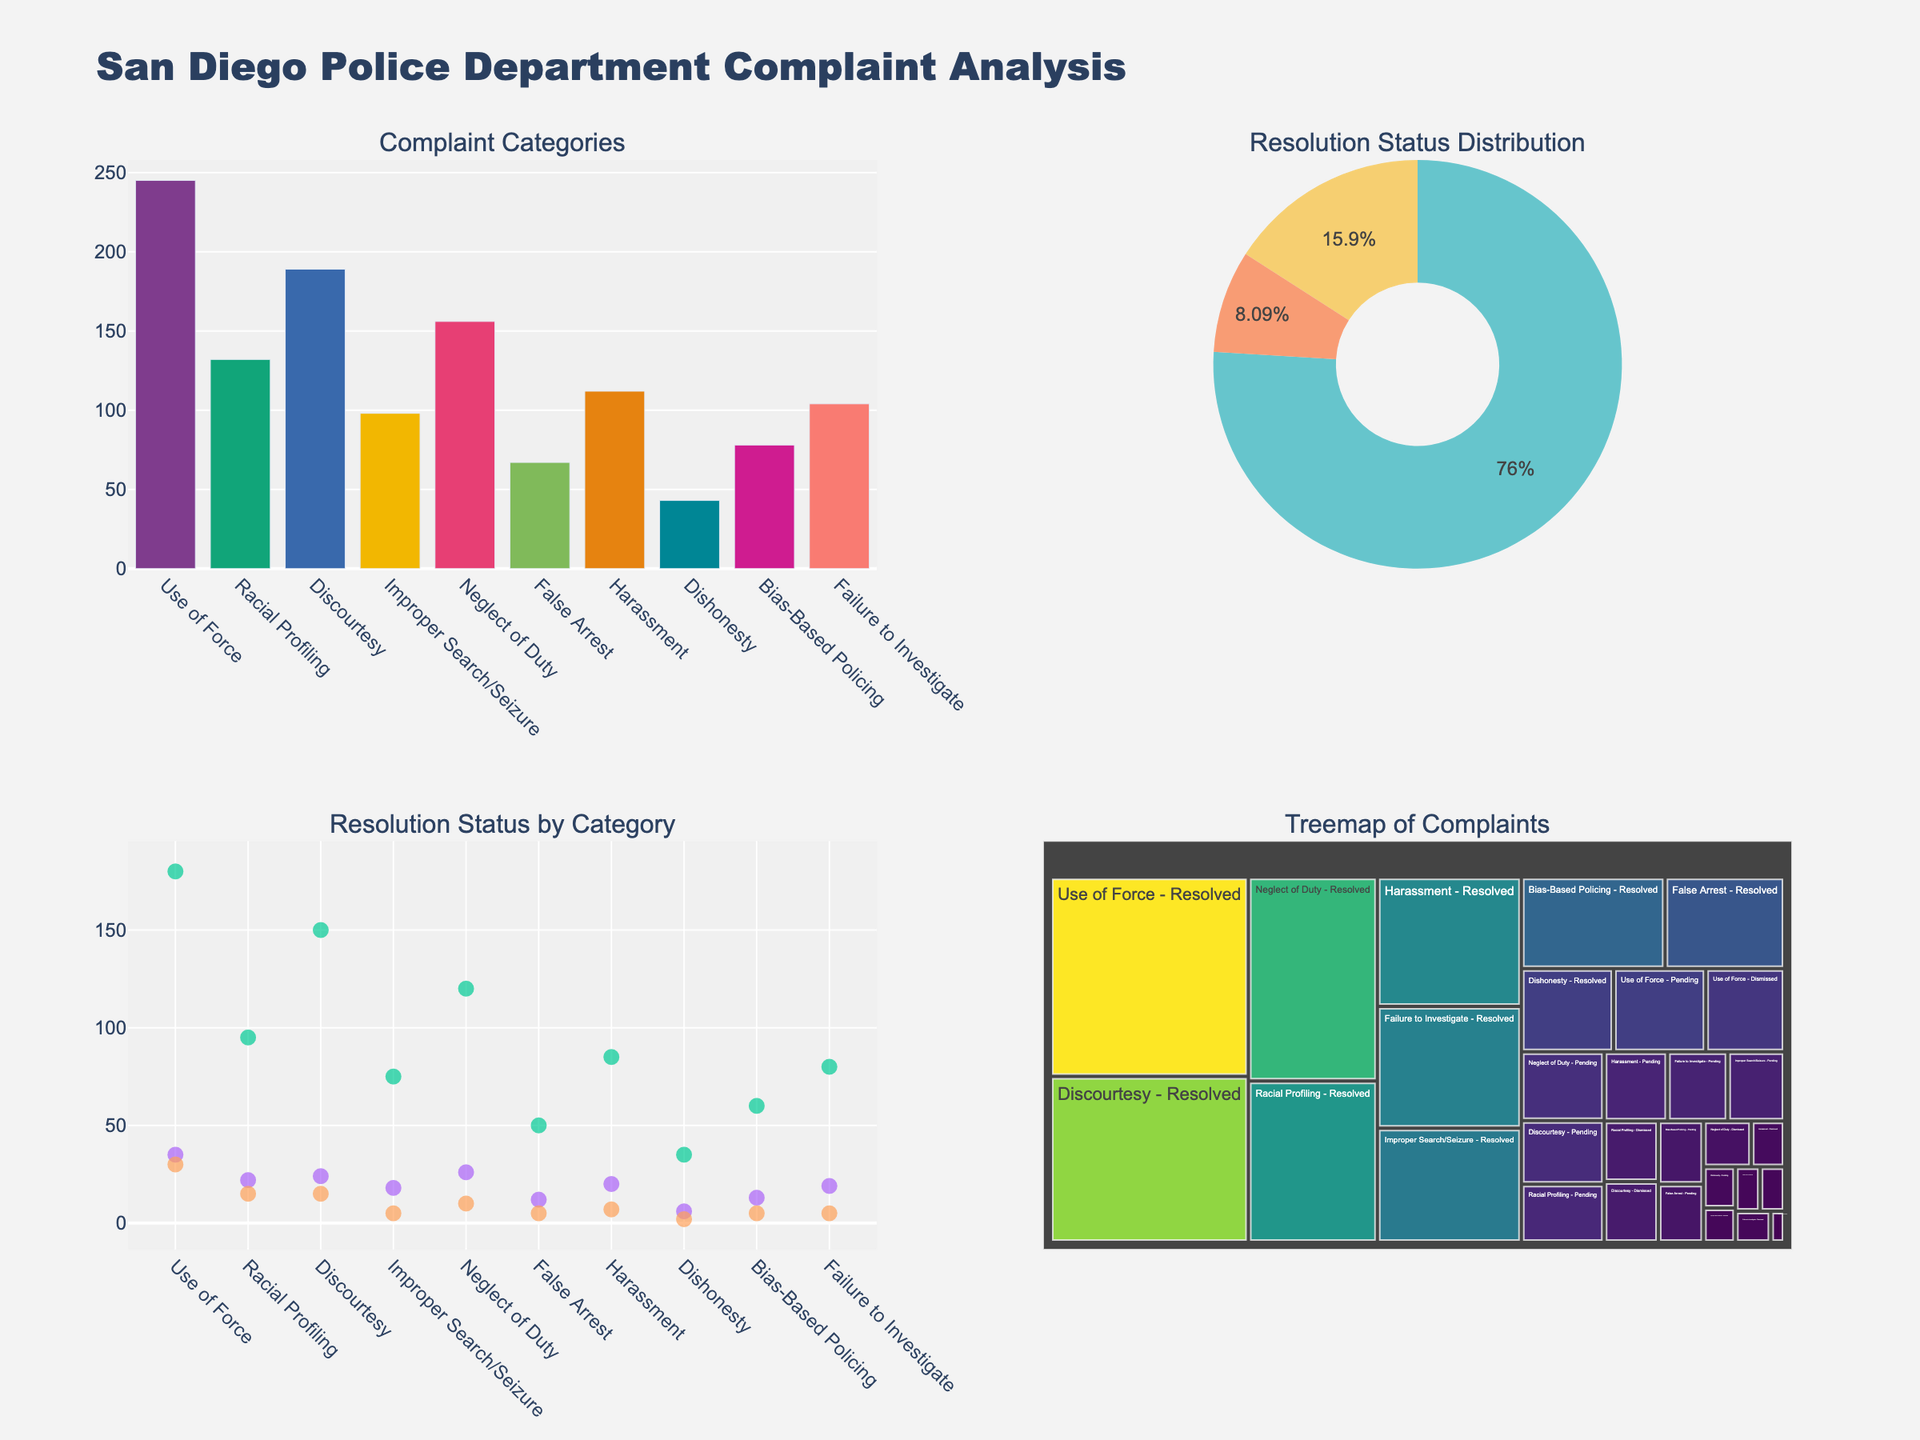What is the title of the overall figure? The title of the overall figure is found at the top and it provides a summary of the content of the figure. The title is "San Diego Police Department Complaint Analysis".
Answer: San Diego Police Department Complaint Analysis How many categories of complaints are there? By looking at the bar chart, we can count the number of distinct categories on the x-axis. There are 10 categories listed which include Use of Force, Racial Profiling, and so on.
Answer: 10 Which complaint category has the most total complaints? In the bar chart, we look for the bar that is the tallest, indicating the highest number of total complaints. The "Use of Force" category has the tallest bar.
Answer: Use of Force What is the total number of "Resolved" cases across all categories? Refer to the scatter plot and add up the height of each "Resolved" marker. The heights, drawn from each category, are 180, 95, 150, 75, 120, 50, 85, 35, 60, and 80. Summing these gives us a total of 930.
Answer: 930 How do the "Pending" cases for "Improper Search/Seizure" compare to "Discourtesy"? In the scatter plot, we see the markers for "Pending" cases in both categories. "Improper Search/Seizure" has 18 pending cases, while "Discourtesy" has 24 pending cases. "Discourtesy" has more pending cases than "Improper Search/Seizure".
Answer: Discourtesy has more What percentage of the total complaints are "Resolved"? Look at the pie chart. To get the percentage of resolved complaints, use the "Resolved" slice of the pie chart. The number of resolved cases is found from the scatter plot totals, 930. Total complaints are the sum of all slices in the pie chart: 930 (Resolved) + 215 (Pending) + 99 (Dismissed) = 1244. Percentage is (930/1244) * 100.
Answer: 74.8% Which category has the lowest number of dismissed complaints? In the scatter plot or treemap, look for the category with the smallest marker or value for "Dismissed". This is "Dishonesty" with only 2 dismissed complaints.
Answer: Dishonesty How are "Total Complaints" distributed among different categories in the treemap? The treemap visually shows the distribution with each category and sub-category (resolved, pending, dismissed) sized according to their complaint count. Larger sections indicate more complaints.
Answer: Larger sections are for Use of Force, Discourtesy; smaller for Dishonesty How many categories have more than 100 resolved cases? From the scatter plot, any category with a marker above 100 on the "Resolved" strip: "Use of Force" (180), "Discourtesy" (150), "Neglect of Duty" (120).
Answer: 3 Is the "Racial Profiling" category experiencing an issue in resolution compared to others? By looking at the relative sizes of the scatter plot markers across categories, "Racial Profiling" has a significant number of "Pending" cases (22) compared to its resolved count (95). Other categories might have a different resolved-to-pending ratio.
Answer: Yes, relatively higher pending compared to resolved 